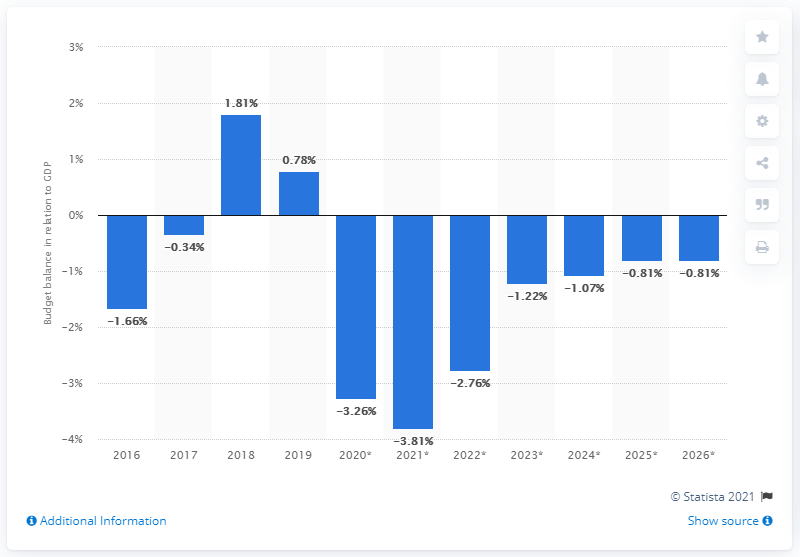Draw attention to some important aspects in this diagram. According to the data, Belarus's budget surplus in 2019 accounted for 0.78% of the country's Gross Domestic Product (GDP). 